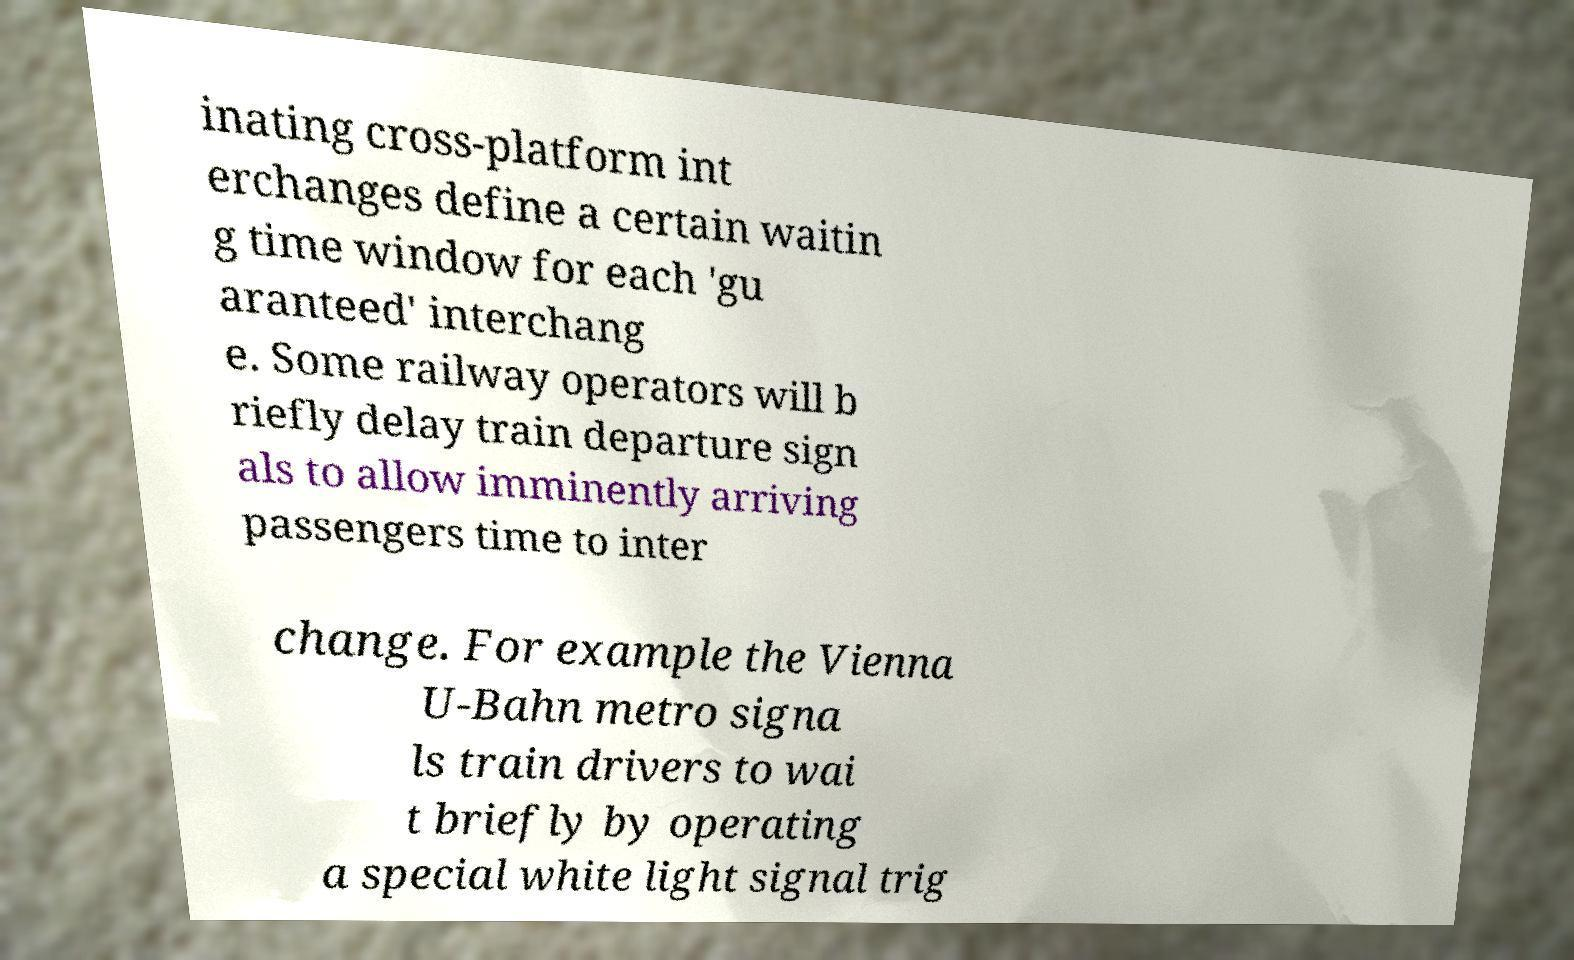I need the written content from this picture converted into text. Can you do that? inating cross-platform int erchanges define a certain waitin g time window for each 'gu aranteed' interchang e. Some railway operators will b riefly delay train departure sign als to allow imminently arriving passengers time to inter change. For example the Vienna U-Bahn metro signa ls train drivers to wai t briefly by operating a special white light signal trig 